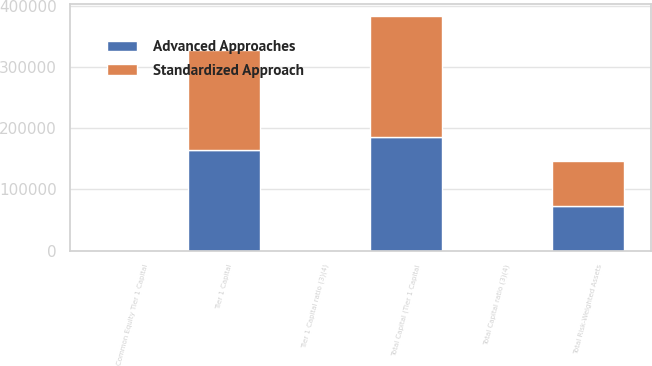Convert chart. <chart><loc_0><loc_0><loc_500><loc_500><stacked_bar_chart><ecel><fcel>Common Equity Tier 1 Capital<fcel>Tier 1 Capital<fcel>Total Capital (Tier 1 Capital<fcel>Total Risk-Weighted Assets<fcel>Tier 1 Capital ratio (3)(4)<fcel>Total Capital ratio (3)(4)<nl><fcel>Advanced Approaches<fcel>12.07<fcel>164036<fcel>186097<fcel>73441<fcel>13.49<fcel>15.3<nl><fcel>Standardized Approach<fcel>12.63<fcel>164036<fcel>198655<fcel>73441<fcel>14.11<fcel>17.08<nl></chart> 